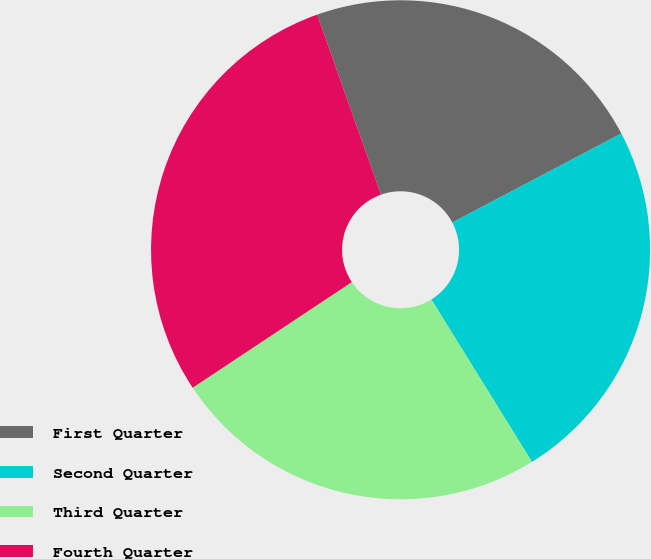Convert chart. <chart><loc_0><loc_0><loc_500><loc_500><pie_chart><fcel>First Quarter<fcel>Second Quarter<fcel>Third Quarter<fcel>Fourth Quarter<nl><fcel>22.71%<fcel>23.89%<fcel>24.5%<fcel>28.9%<nl></chart> 